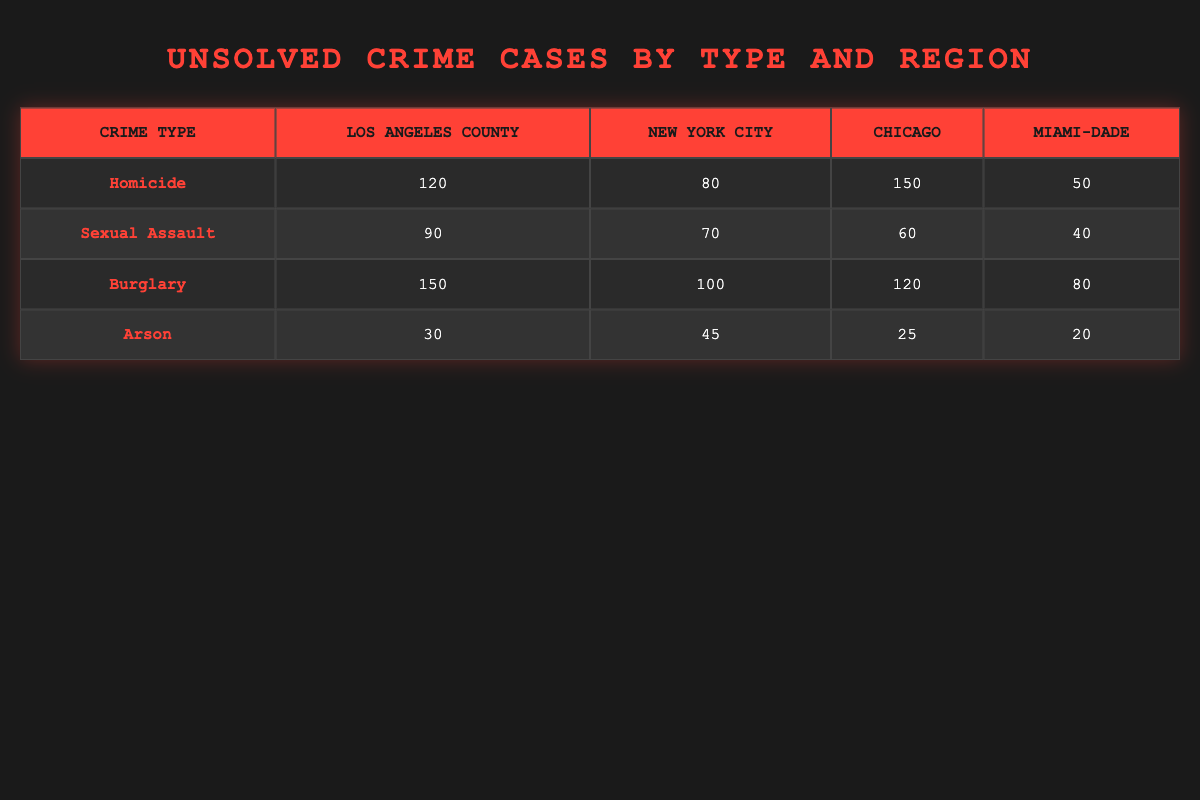What type of unsolved crime has the highest count in Los Angeles County? The unsolved crime type with the highest count in Los Angeles County is Burglary, with 150 unsolved cases.
Answer: Burglary How many unsolved homicide cases are reported in Chicago? The table shows that there are 150 unsolved homicide cases reported in Chicago.
Answer: 150 Which city has the highest number of unsolved sexual assault cases? By comparing the numbers, Los Angeles County has the highest count of unsolved sexual assault cases, totaling 90.
Answer: Los Angeles County What is the total number of unsolved arson cases across all regions? The total number of unsolved arson cases can be calculated by summing the cases from each region: 30 (Los Angeles) + 45 (New York) + 25 (Chicago) + 20 (Miami-Dade) = 120.
Answer: 120 Are there more unsolved burglary cases in New York City or Miami-Dade? In New York City, there are 100 unsolved burglary cases, while in Miami-Dade, there are 80, making New York City higher.
Answer: Yes, more in New York City Which region has the least number of unsolved sexual assault cases? By reviewing the counts, Miami-Dade has the least number of unsolved sexual assault cases, totaling 40.
Answer: Miami-Dade What is the difference in unsolved homicide cases between Chicago and New York City? The difference is determined by subtracting the number of homicides in New York City (80) from Chicago (150): 150 - 80 = 70.
Answer: 70 If we group the total unsolved crimes by type, which type has more total cases: Sexual Assault or Burglary? The total for Sexual Assault is 90 (Los Angeles) + 70 (New York) + 60 (Chicago) + 40 (Miami-Dade) = 260. For Burglary, it is 150 + 100 + 120 + 80 = 450. Since 450 (Burglary) is greater than 260 (Sexual Assault), Burglary has more cases.
Answer: Burglary has more total cases 